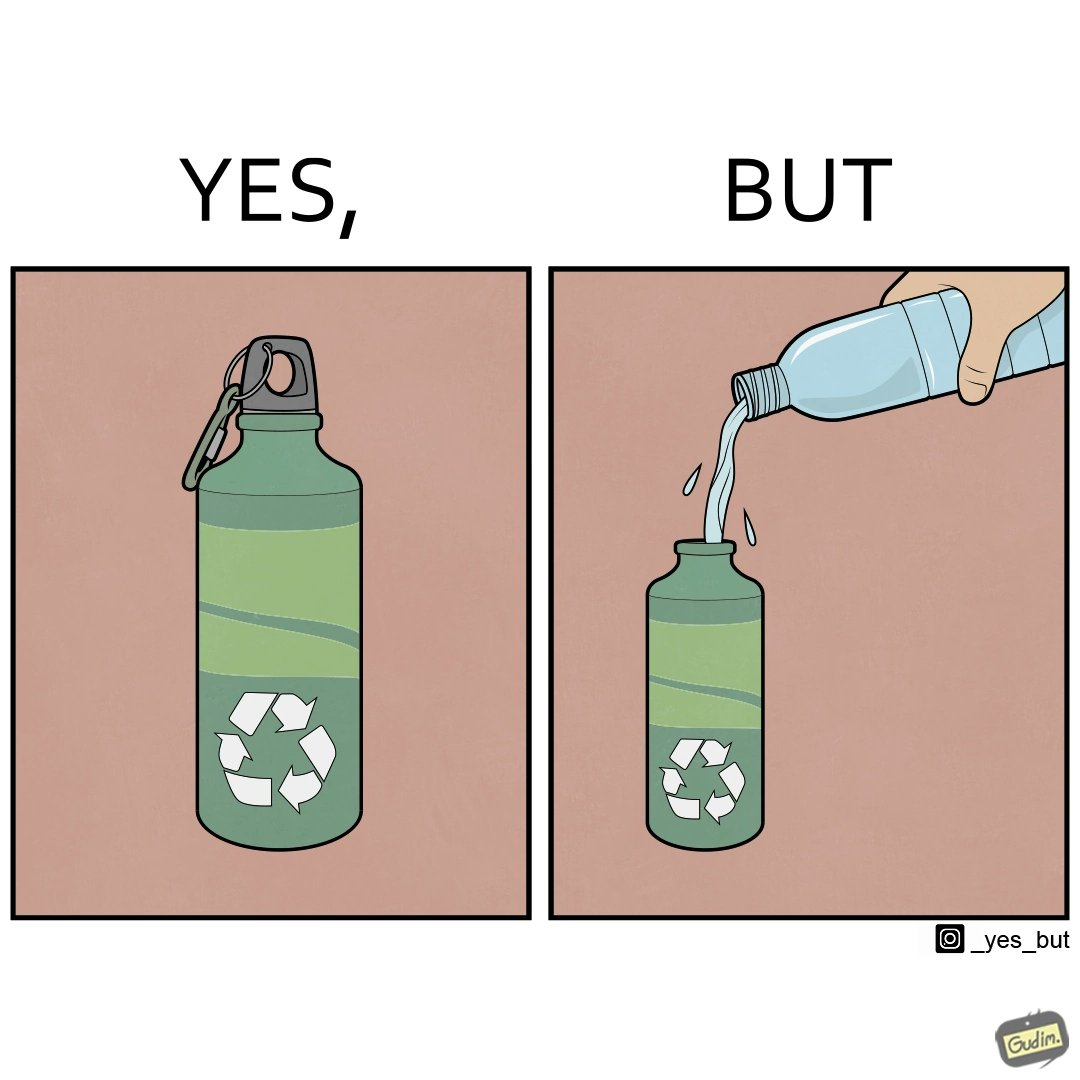Describe what you see in this image. The images are ironic since the metallic water bottle aims to be more sustainable as can be seen from the sign on the bottle but its user fills it with a plastic bottle which destroys its purpose 